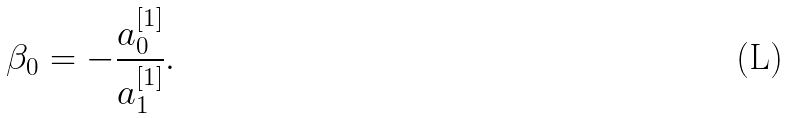<formula> <loc_0><loc_0><loc_500><loc_500>\beta _ { 0 } = - \frac { a _ { 0 } ^ { [ 1 ] } } { a _ { 1 } ^ { [ 1 ] } } .</formula> 